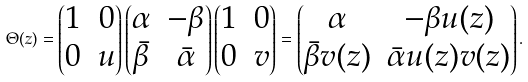<formula> <loc_0><loc_0><loc_500><loc_500>\Theta ( z ) = \begin{pmatrix} 1 & 0 \\ 0 & u \end{pmatrix} \begin{pmatrix} \alpha & - \beta \\ \bar { \beta } & \bar { \alpha } \end{pmatrix} \begin{pmatrix} 1 & 0 \\ 0 & v \end{pmatrix} = \begin{pmatrix} \alpha & - \beta u ( z ) \\ \bar { \beta } v ( z ) & \bar { \alpha } u ( z ) v ( z ) \end{pmatrix} .</formula> 